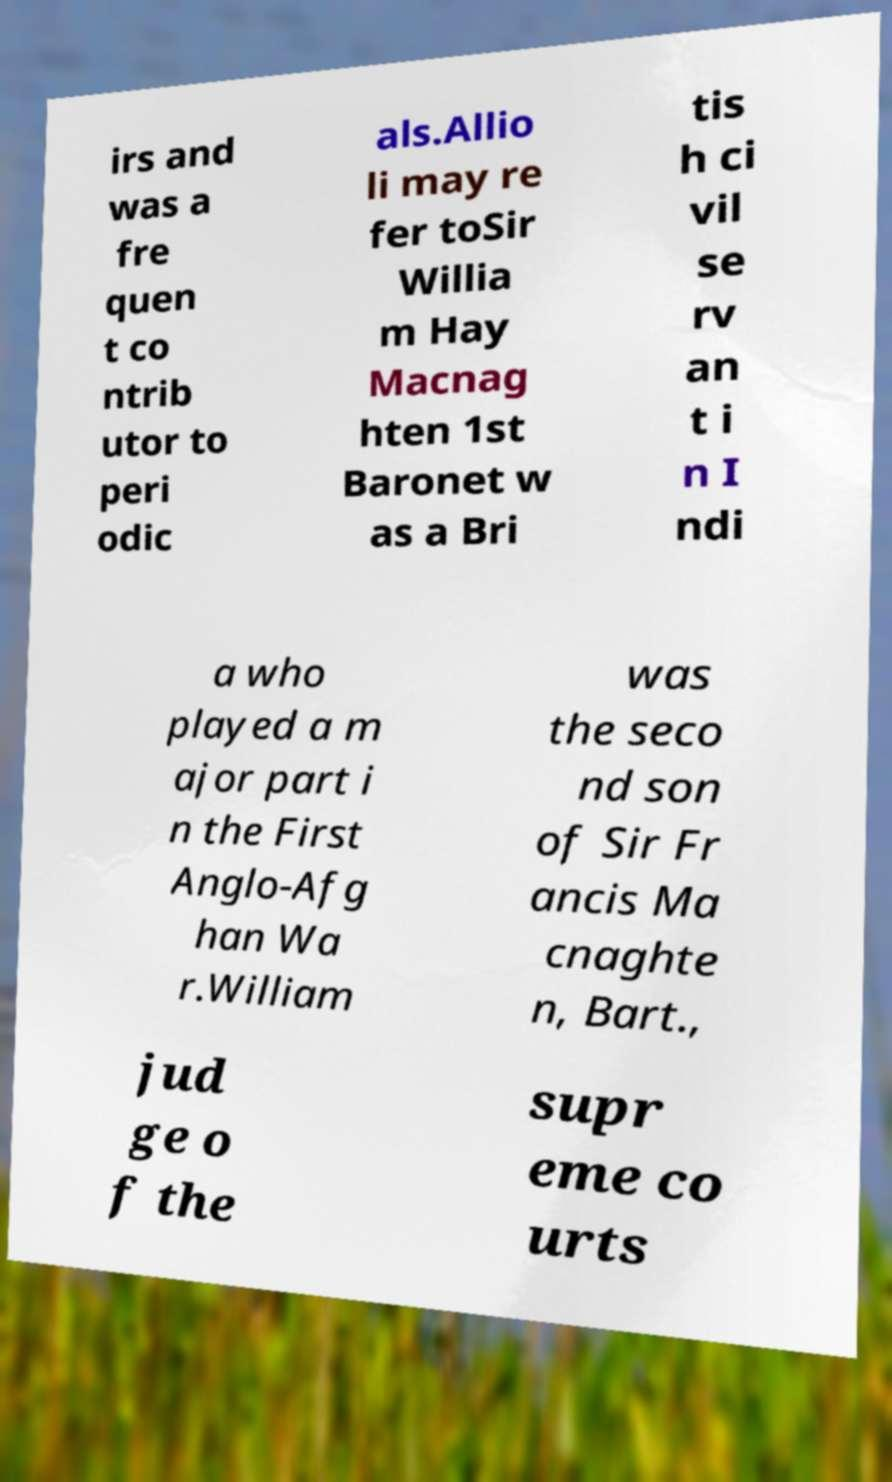What messages or text are displayed in this image? I need them in a readable, typed format. irs and was a fre quen t co ntrib utor to peri odic als.Allio li may re fer toSir Willia m Hay Macnag hten 1st Baronet w as a Bri tis h ci vil se rv an t i n I ndi a who played a m ajor part i n the First Anglo-Afg han Wa r.William was the seco nd son of Sir Fr ancis Ma cnaghte n, Bart., jud ge o f the supr eme co urts 